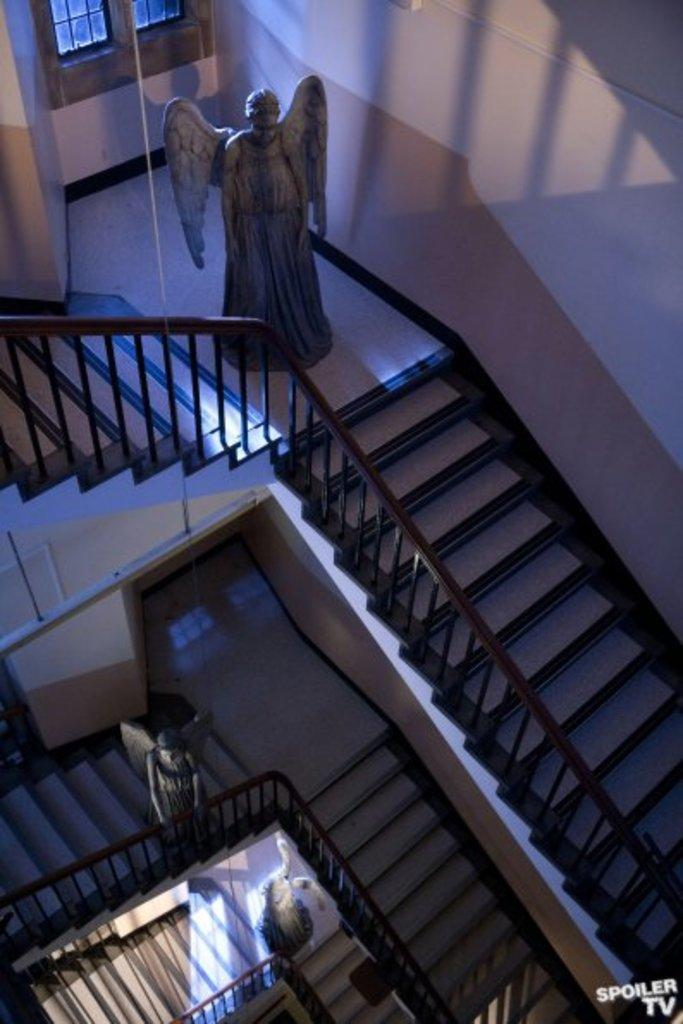What is the main structure in the center of the image? There is a building in the center of the image. What can be seen on the sides of the building? There is a wall and a window in the image. What is attached to the wall? There is a rope in the image. What type of objects are present in the image? There are statues and other objects in the image. How can one access the upper levels of the building? There is a staircase in the image. What type of glove is being used in the competition in the image? There is no competition or glove present in the image. How does the image draw attention to the architectural details of the building? The image does not actively draw attention to the architectural details of the building; it simply presents the building and its surroundings. 